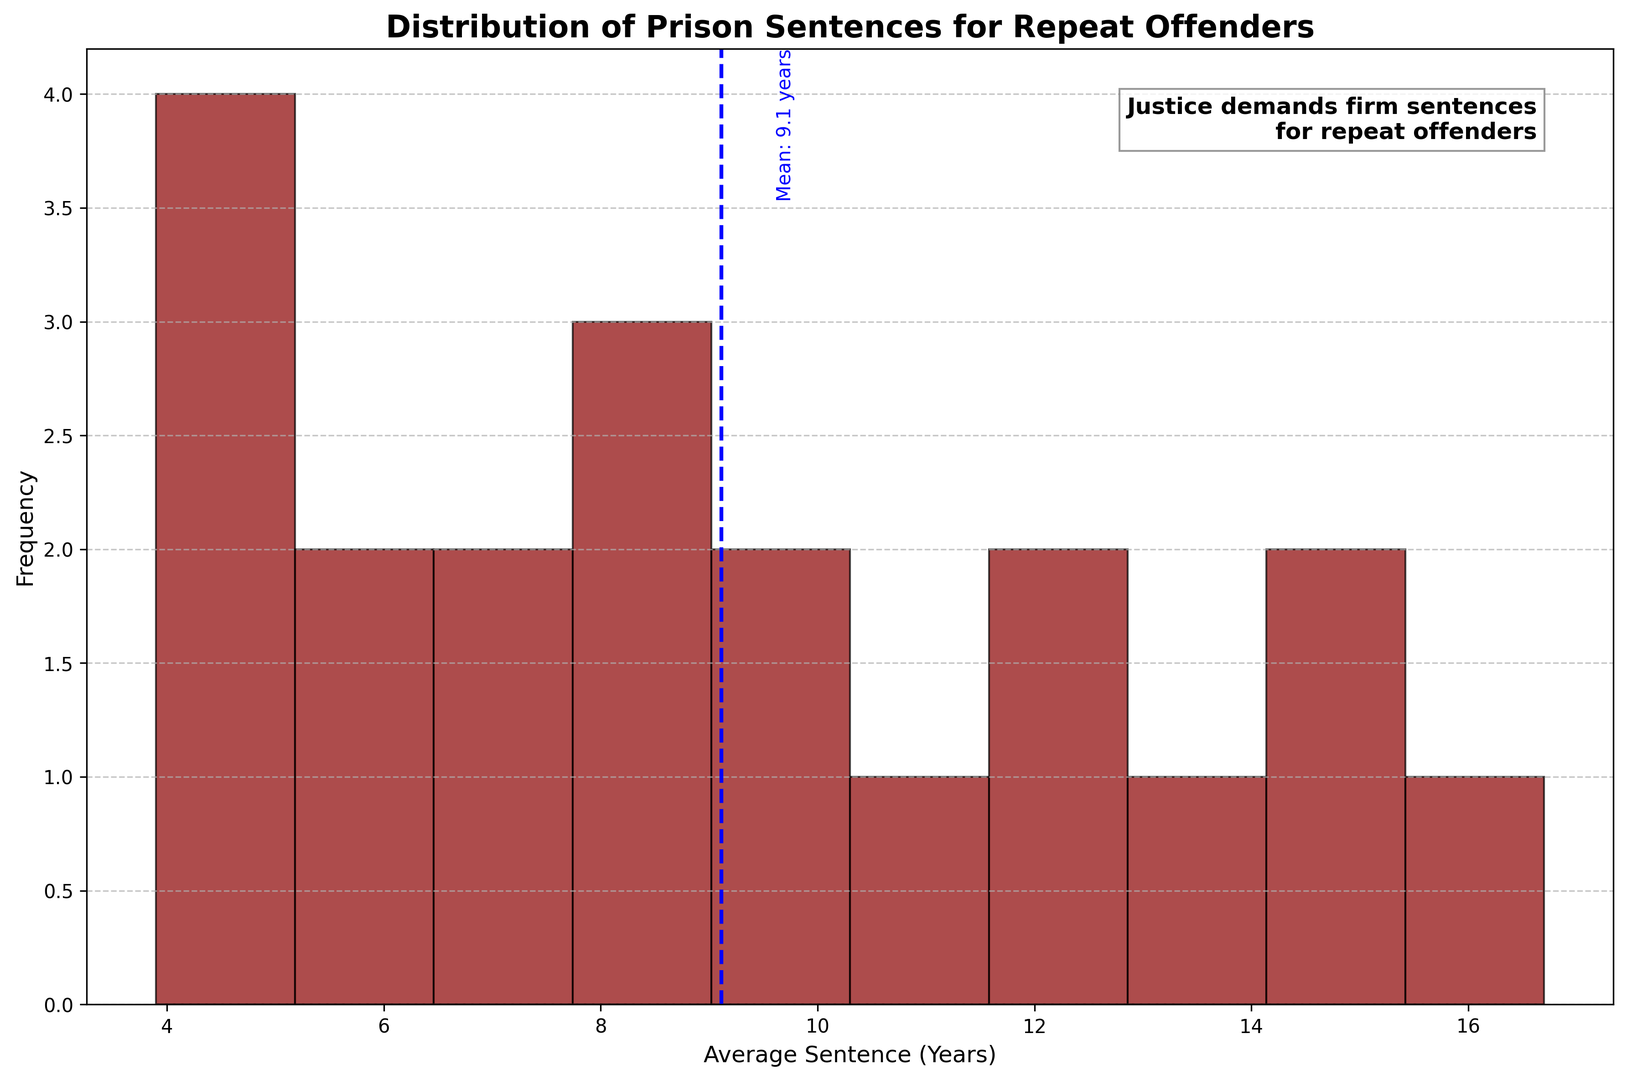What is the most common category of prison sentence lengths for repeat offenders? To find the most common category, we need to look at the tallest bar in the histogram. This bar represents the bin with the highest frequency.
Answer: The bin that covers 4-6 years Which crime category has been highlighted with an average sentence around the mean? First, identify the mean sentence line, which is marked at 9.4 years. Then look for crime categories whose average sentence is close to 9.4 years.
Answer: Drug Offenses What crime categories fall into the 10-12 years sentence range? Check all bars that fall within 10-12 years range on x-axis. Then refer to the crime categories that match these bins.
Answer: Robbery, Assault How does the frequency of sentences in the 11-13 years range compare to the frequency in the 5-7 years range? Compare the heights of bars representing 11-13 years and 5-7 years on the histogram to find out which is taller or shorter.
Answer: The range 5-7 years has a higher frequency Which crime category has the shortest average sentence? Find the bar closest to the 0-year mark on the x-axis and check the crime category associated with it.
Answer: Cybercrime How many categories have average sentences greater than the mean sentence (9.4 years)? Count all the bars located to the right of the mean line.
Answer: 9 Can you identify the crime category with the highest average sentence? Look for the tallest or rightmost bar in the histogram and identify its crime category.
Answer: Human Trafficking Are there more crime categories with average sentences below 10 years or above 10 years? Count the number of bars to the left and to the right of the 10 years mark and compare these counts.
Answer: More below 10 years What can be inferred about the sentences for violent crimes compared to property crimes? Analyze the position of the bar for violent crimes in comparison to the bar for property crimes on the x-axis.
Answer: Violent crimes have longer sentences How does the frequency of sentences in the 8-10 years range compare to those in the 15-17 years range? Compare the heights of the bars corresponding to the 8-10 years range and 15-17 years range on the x-axis.
Answer: 8-10 years has higher frequency 